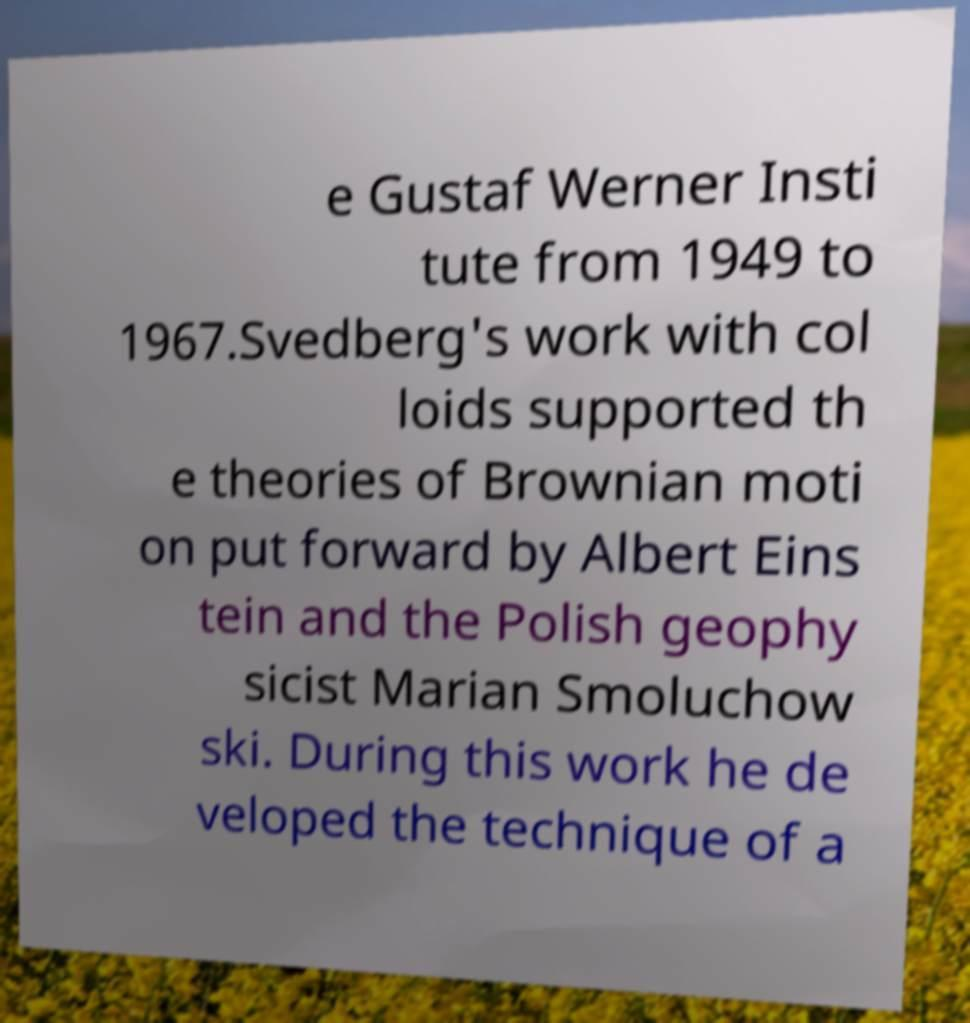Can you accurately transcribe the text from the provided image for me? e Gustaf Werner Insti tute from 1949 to 1967.Svedberg's work with col loids supported th e theories of Brownian moti on put forward by Albert Eins tein and the Polish geophy sicist Marian Smoluchow ski. During this work he de veloped the technique of a 